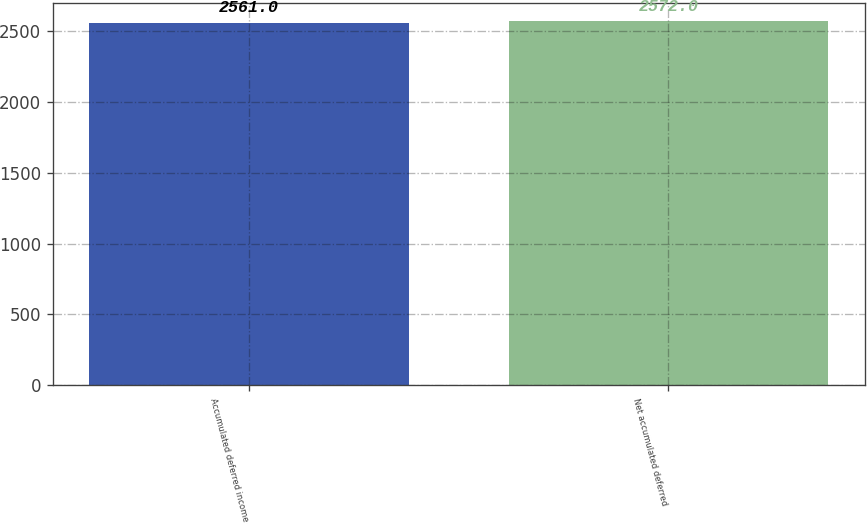<chart> <loc_0><loc_0><loc_500><loc_500><bar_chart><fcel>Accumulated deferred income<fcel>Net accumulated deferred<nl><fcel>2561<fcel>2572<nl></chart> 